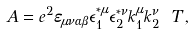Convert formula to latex. <formula><loc_0><loc_0><loc_500><loc_500>A = e ^ { 2 } \varepsilon _ { \mu \nu \alpha \beta } \epsilon _ { 1 } ^ { * \mu } \epsilon _ { 2 } ^ { * \nu } k _ { 1 } ^ { \mu } k _ { 2 } ^ { \nu } \ T \, ,</formula> 